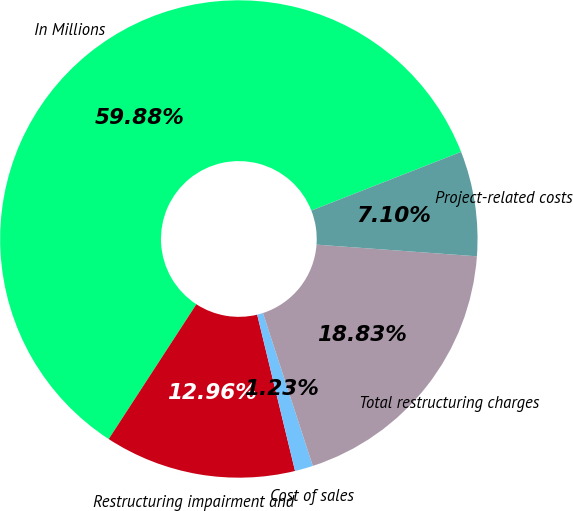Convert chart. <chart><loc_0><loc_0><loc_500><loc_500><pie_chart><fcel>In Millions<fcel>Restructuring impairment and<fcel>Cost of sales<fcel>Total restructuring charges<fcel>Project-related costs<nl><fcel>59.88%<fcel>12.96%<fcel>1.23%<fcel>18.83%<fcel>7.1%<nl></chart> 